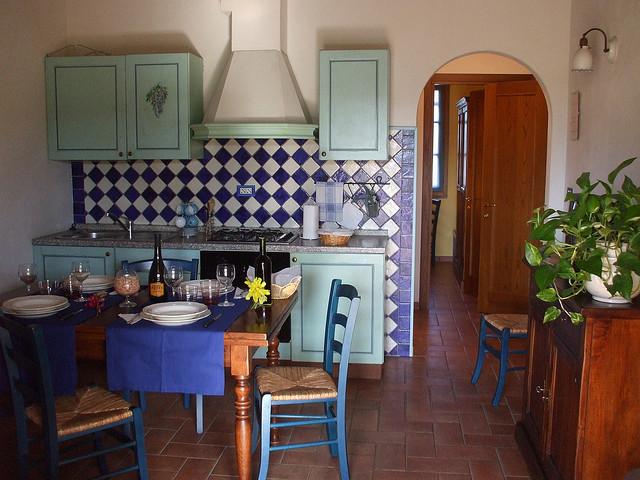Is this a new kitchen?
Quick response, please. No. What color is the tablecloth?
Answer briefly. Blue. What is this room called?
Concise answer only. Kitchen. What kind of floor material was used?
Write a very short answer. Tile. Are the tiles on the floor all pointing the same direction?
Be succinct. No. What color are the tiles on the wall?
Write a very short answer. Blue and white. Are the kitchen lights on?
Concise answer only. No. Is the kitchen cluttered?
Concise answer only. No. What type of plant is in the room?
Short answer required. Ivy. Is this a new apartment?
Write a very short answer. No. Is this a bachelor pad?
Answer briefly. No. 